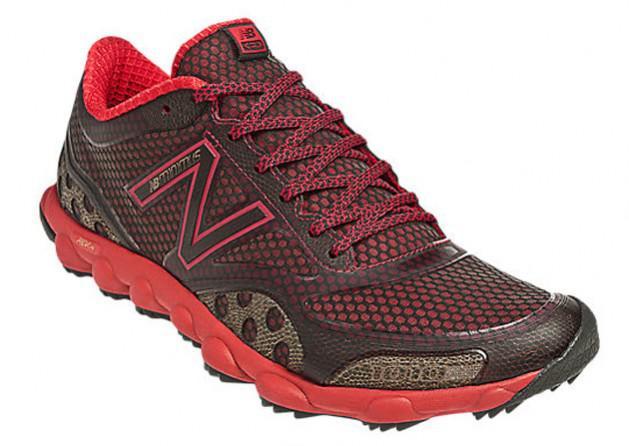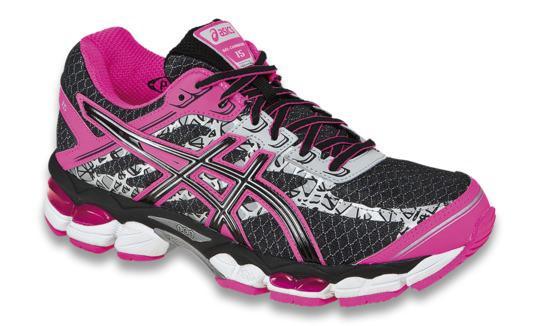The first image is the image on the left, the second image is the image on the right. For the images shown, is this caption "The shoe style in one image is black with pink and white accents, and tied with black laces with pink edging." true? Answer yes or no. Yes. The first image is the image on the left, the second image is the image on the right. For the images shown, is this caption "Each image contains exactly one athletic shoe shown at an angle." true? Answer yes or no. Yes. 